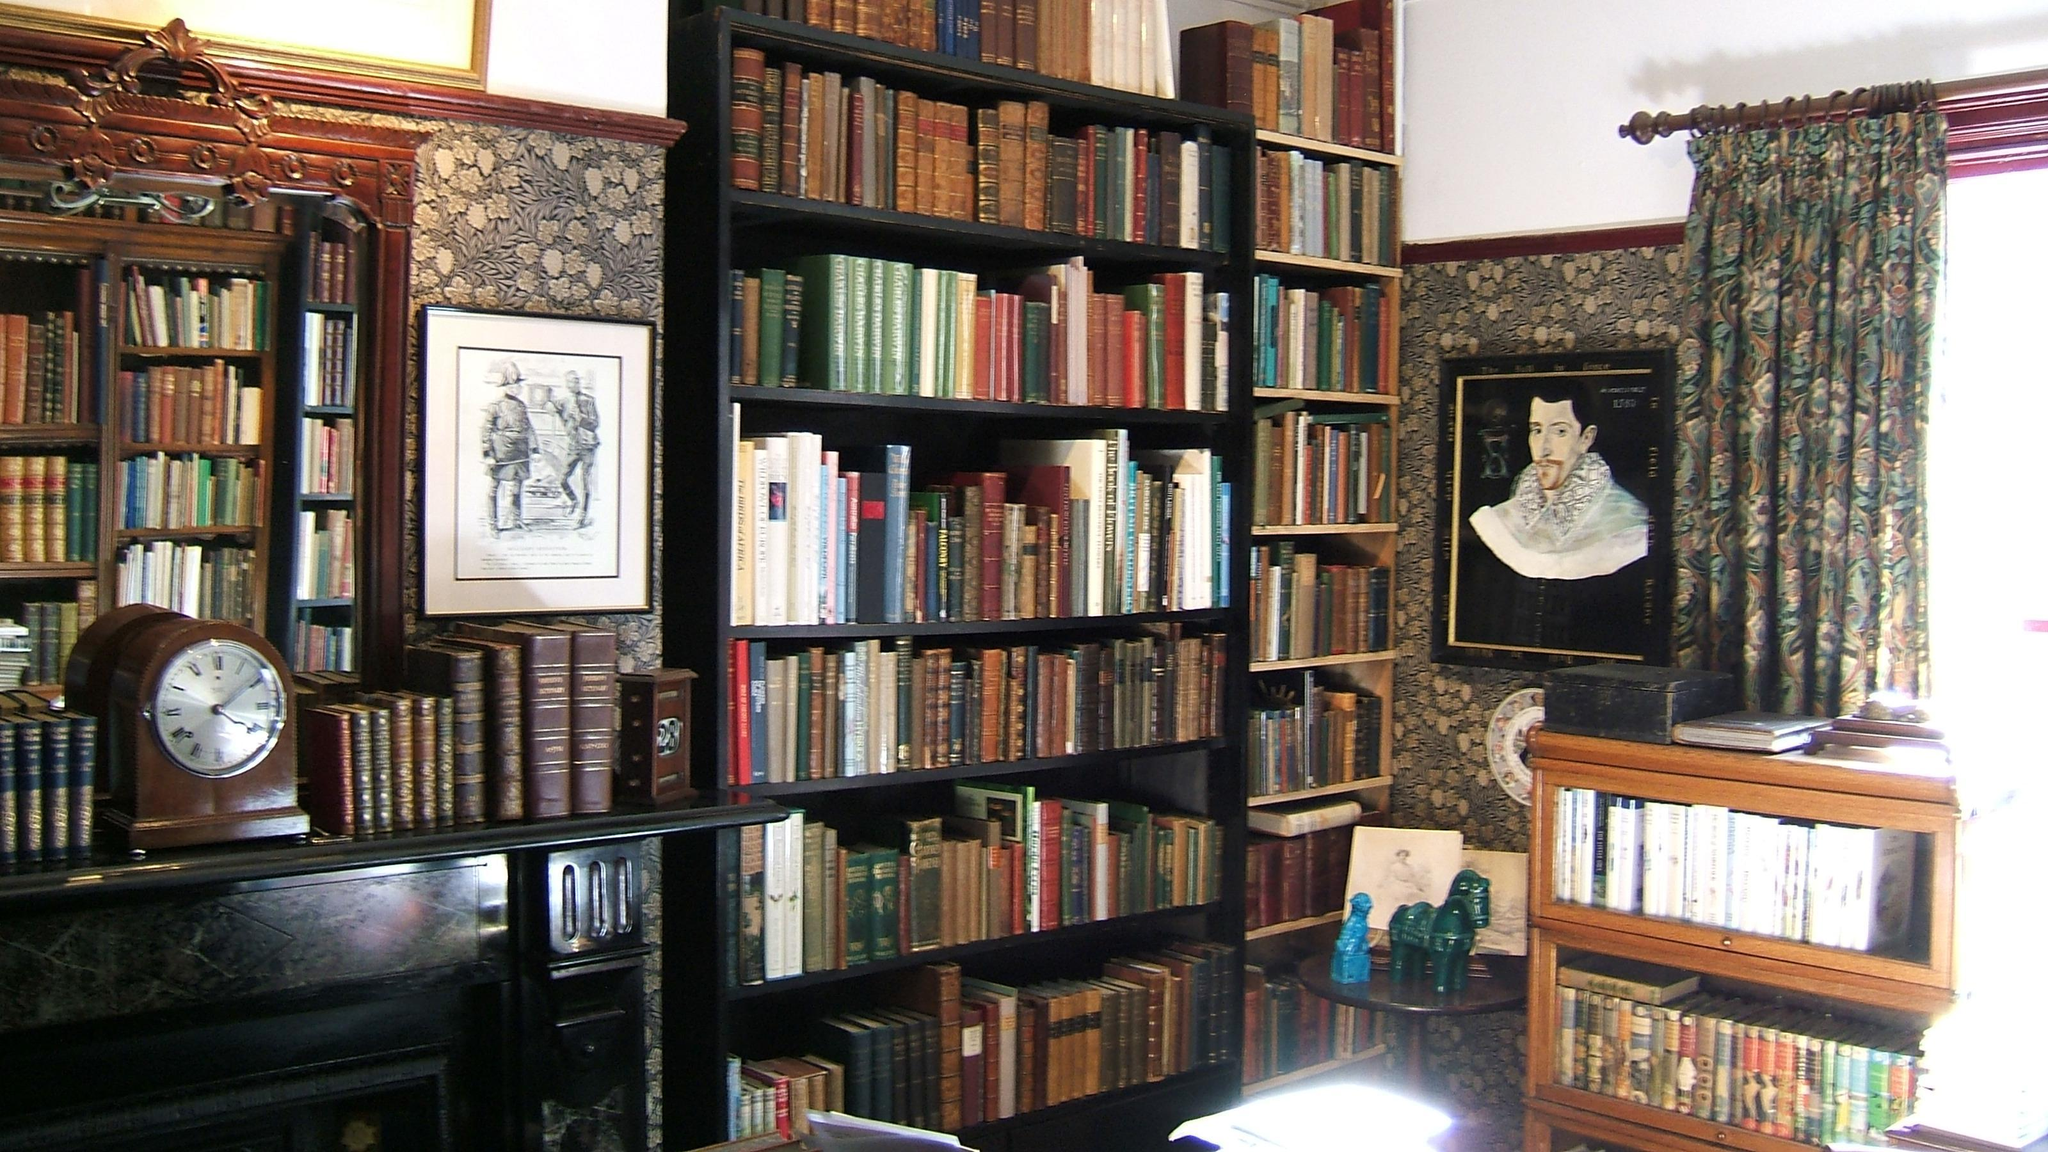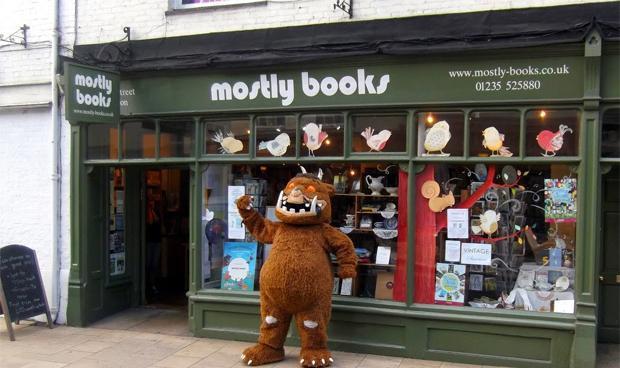The first image is the image on the left, the second image is the image on the right. Assess this claim about the two images: "One image shows an upright furry cartoonish creature in front of items displayed for sale.". Correct or not? Answer yes or no. Yes. The first image is the image on the left, the second image is the image on the right. Considering the images on both sides, is "One of the images features a large stuffed animal/character from a popular book." valid? Answer yes or no. Yes. 